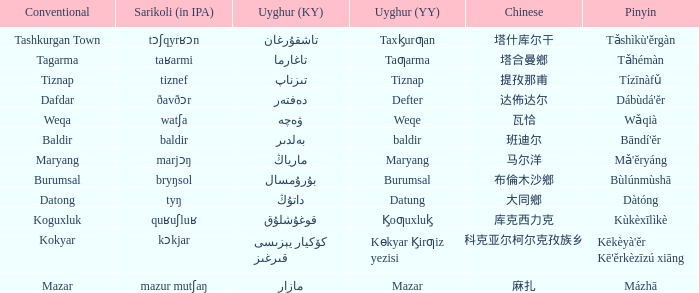Name the conventional for defter Dafdar. 